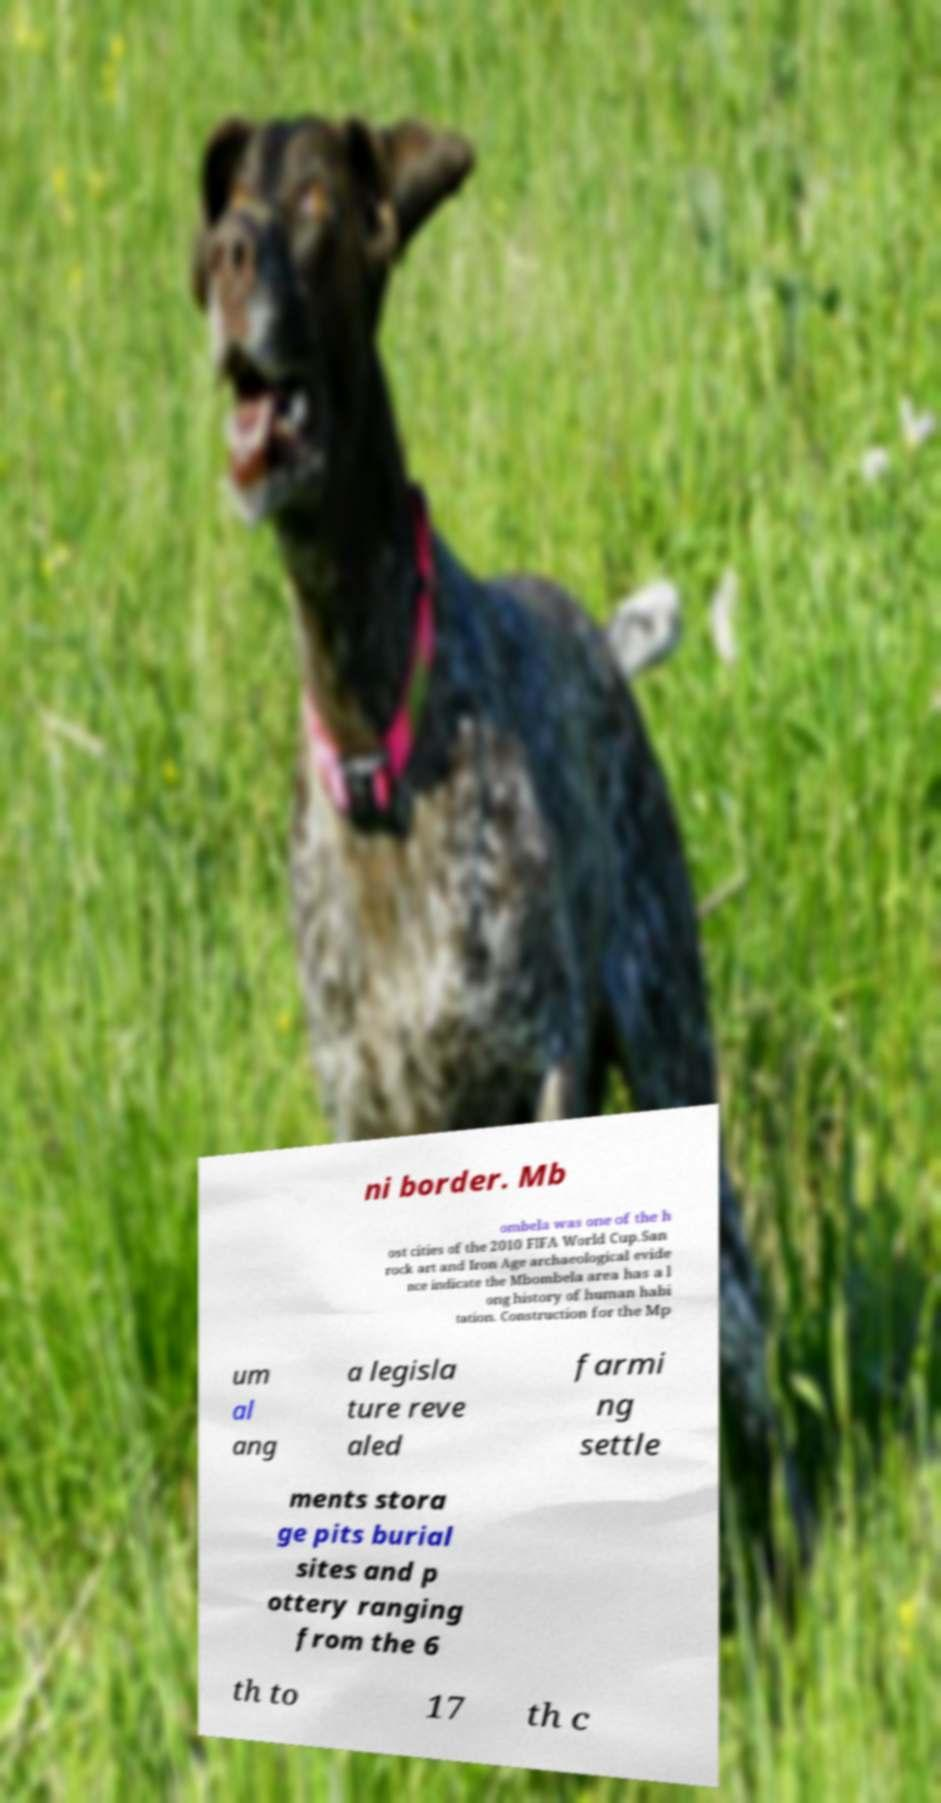Can you accurately transcribe the text from the provided image for me? ni border. Mb ombela was one of the h ost cities of the 2010 FIFA World Cup.San rock art and Iron Age archaeological evide nce indicate the Mbombela area has a l ong history of human habi tation. Construction for the Mp um al ang a legisla ture reve aled farmi ng settle ments stora ge pits burial sites and p ottery ranging from the 6 th to 17 th c 